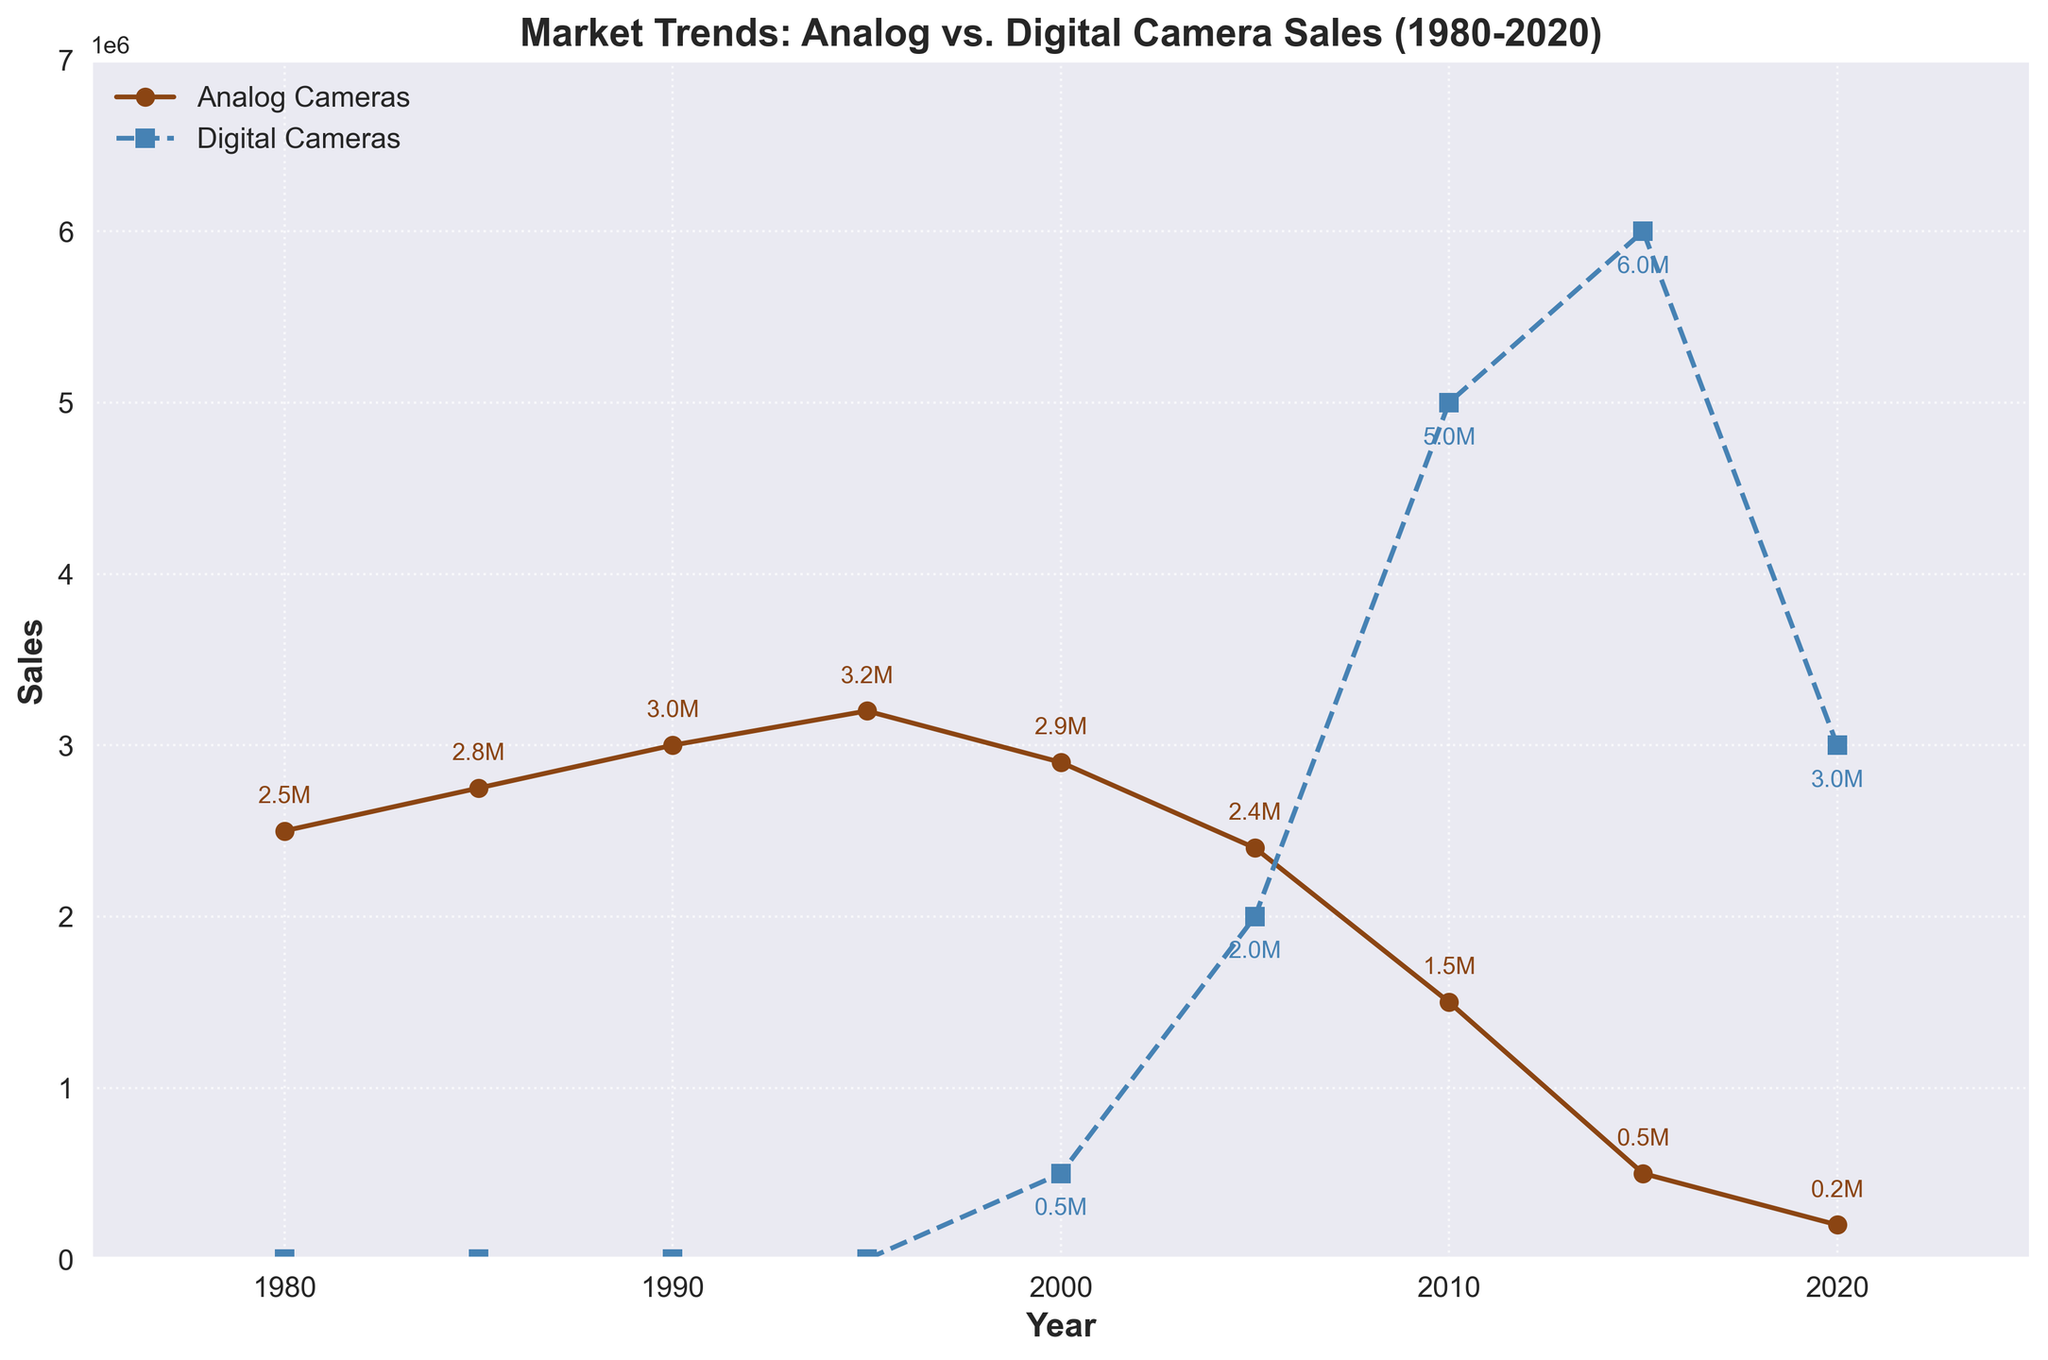What's the title of the plot? The title of the plot is located at the top of the figure. It reads 'Market Trends: Analog vs. Digital Camera Sales (1980-2020)'.
Answer: Market Trends: Analog vs. Digital Camera Sales (1980-2020) How many data points are present in the plot? Each data point corresponds to a year, marked by either a circle for analog camera sales or a square for digital camera sales. Counting them, there are 9 data points for each camera type.
Answer: 9 In which year did digital camera sales surpass analog camera sales? By observing the lines, digital camera sales surpassed analog camera sales around the year 2010.
Answer: 2010 What is the highest sales figure for digital cameras? The highest point on the digital camera sales line, annotated, is 6.0 million units in 2015.
Answer: 6.0 million units in 2015 What are the analog camera sales in 1990? Looking at the annotations on the analog camera line for the year 1990, the sales figure is 3.0 million units.
Answer: 3.0 million units What is the difference in analog camera sales between 2000 and 2010? From the plot, analog camera sales in 2000 are 2.9 million units and in 2010 are 1.5 million units. The difference is 2.9 million - 1.5 million = 1.4 million units.
Answer: 1.4 million units By how much did digital camera sales increase from 2000 to 2005? Digital camera sales were 0.5 million units in 2000 and increased to 2.0 million units in 2005. The increase is 2.0 million - 0.5 million = 1.5 million units.
Answer: 1.5 million units Which year shows the largest decline in analog camera sales from the previous data point? The largest decline can be found by looking for the steepest downward slope between years. This is between 2010 and 2015, with sales dropping from 1.5 million to 0.5 million units, a decline of 1.0 million units.
Answer: 2010 to 2015 What are the sales figures for both analog and digital cameras in 2005? From the plot annotations, analog camera sales are 2.4 million units, and digital camera sales are 2.0 million units in 2005.
Answer: 2.4 million units for analog, 2.0 million units for digital By what factor did digital camera sales increase from 2000 to 2015? Digital camera sales were 0.5 million units in 2000 and increased to 6.0 million units in 2015. The factor increase is 6.0 / 0.5 = 12 times.
Answer: 12 times 